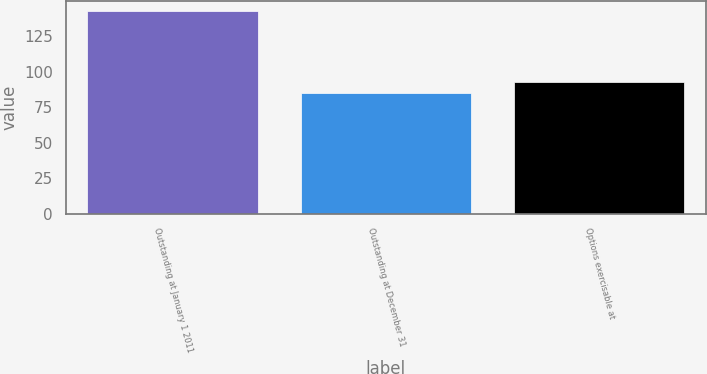Convert chart to OTSL. <chart><loc_0><loc_0><loc_500><loc_500><bar_chart><fcel>Outstanding at January 1 2011<fcel>Outstanding at December 31<fcel>Options exercisable at<nl><fcel>142.2<fcel>84.64<fcel>92.98<nl></chart> 